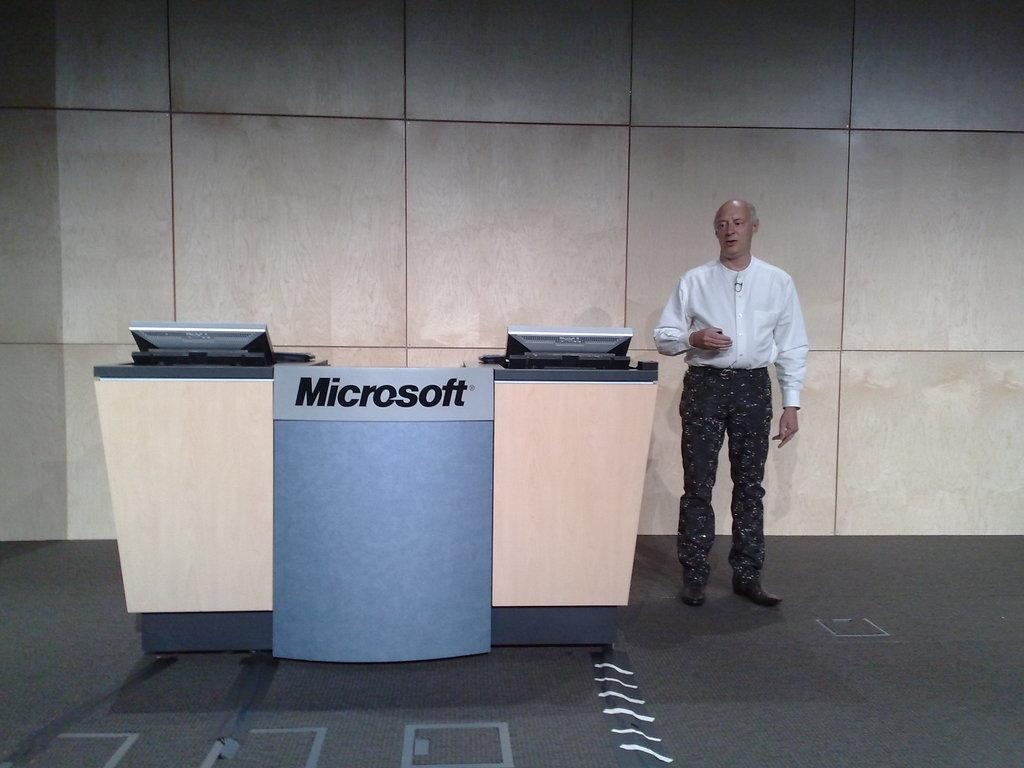<image>
Render a clear and concise summary of the photo. Man standing next to a desk which says "Microsoft". 